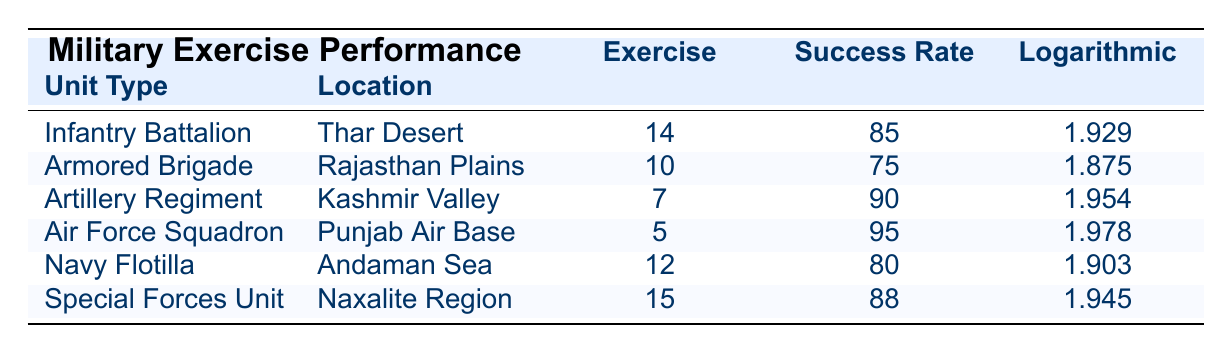What is the success rate percentage of the Air Force Squadron? Referring to the table, the success rate percentage for the Air Force Squadron is listed directly under the success rate column.
Answer: 95 What is the location of the Special Forces Unit? The location of the Special Forces Unit can be found in the table under the location column. It shows "Naxalite Region."
Answer: Naxalite Region Which unit type has the highest logarithmic success rate? Looking at the logarithmic success rate values in the table, the Air Force Squadron has the highest value of 1.978.
Answer: Air Force Squadron What is the average exercise duration for all units listed? To find the average exercise duration, sum the exercise durations (14 + 10 + 7 + 5 + 12 + 15 = 63) and divide by the number of units (6): 63 / 6 = 10.5 days.
Answer: 10.5 days Is the success rate of the Artillery Regiment more than 85%? The success rate of the Artillery Regiment is 90%, which is indeed more than 85%.
Answer: Yes Which unit category spent more days on the exercise, the Infantry Battalion or the Navy Flotilla? The Infantry Battalion spent 14 days on the exercise, while the Navy Flotilla spent 12 days. Since 14 is greater than 12, the Infantry Battalion spent more days.
Answer: Infantry Battalion What is the difference in success rates between the Special Forces Unit and the Armored Brigade? The success rate for the Special Forces Unit is 88%, and for the Armored Brigade, it is 75%. The difference is calculated as 88 - 75 = 13%.
Answer: 13% Did any unit have a success rate below 80%? Checking the success rates, the Armored Brigade is the only unit with a success rate of 75%, which is below 80%.
Answer: Yes How many units had a logarithmic success rate above 1.9? Upon examining the logarithmic success rates, the Infantry Battalion (1.929), Artillery Regiment (1.954), Air Force Squadron (1.978), and Special Forces Unit (1.945) all have values above 1.9. This makes a total of 4 units.
Answer: 4 